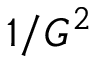Convert formula to latex. <formula><loc_0><loc_0><loc_500><loc_500>1 / { G } ^ { 2 }</formula> 